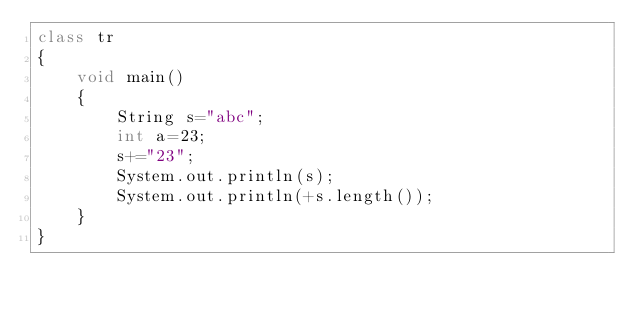<code> <loc_0><loc_0><loc_500><loc_500><_Java_>class tr
{
    void main()
    {
        String s="abc";
        int a=23;
        s+="23";
        System.out.println(s);
        System.out.println(+s.length());
    }
}</code> 